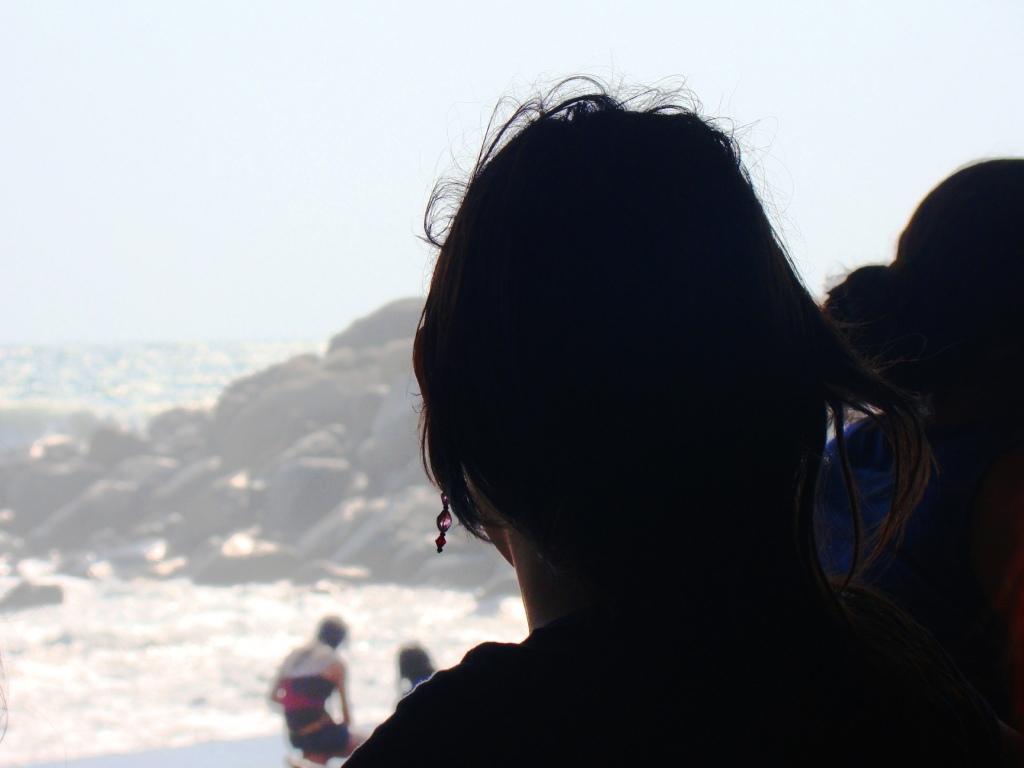Please provide a concise description of this image. In this image, we can see a person. There is a rock in the middle of the image. There is an another person at the bottom of the image. In the background of the image, there is a sky. 